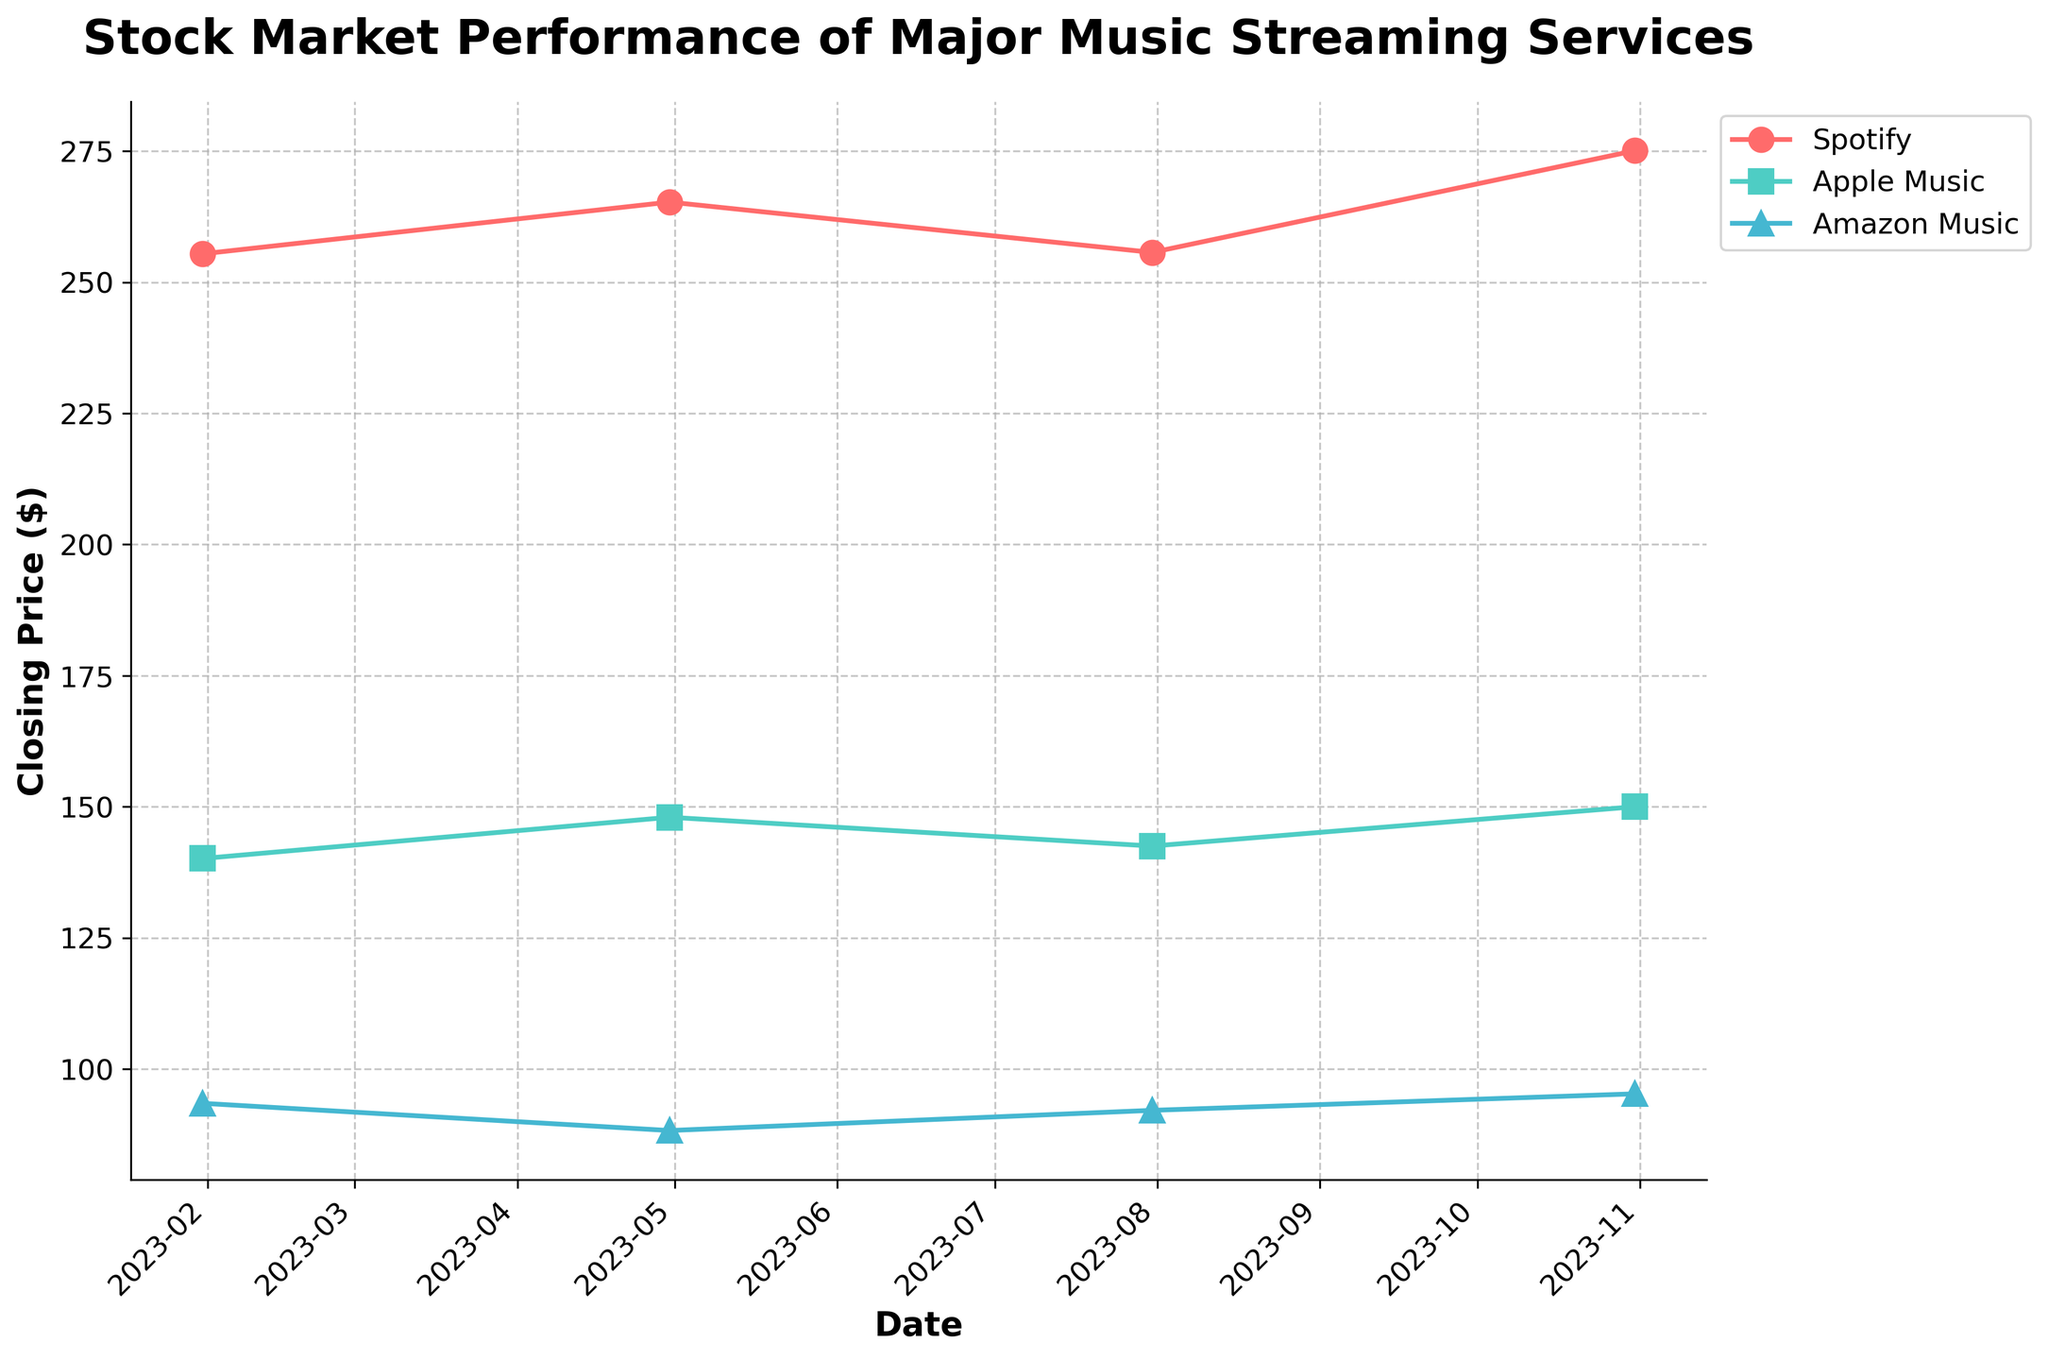What is the title of the figure? The title is located at the top of the figure, usually in a larger and bold font to indicate it's the main heading. The title summarizes the main topic or purpose of the figure.
Answer: Stock Market Performance of Major Music Streaming Services How many companies are represented in the figure? To find out how many companies are represented, look at the legends or lines on the plot. Each color and marker type represents a different company.
Answer: Three Which company has the highest closing price on January 31, 2023? Located the data points for January 31, 2023, and compare the closing prices among the companies. The company with the highest data point on that date is the answer.
Answer: Spotify Did Apple Music's stock price increase or decrease from July 31 to October 31, 2023? Compare the closing prices of Apple Music on July 31 and October 31, 2023. A higher value on October 31 indicates an increase, while a lower value indicates a decrease.
Answer: Increase What is the closing price of Amazon Music on July 31, 2023? Find the date July 31, 2023, on the x-axis, then look at Amazon Music’s line to find the corresponding y-value.
Answer: 92.10 Which company had the lowest closing price on October 31, 2023? Compare the closing prices of all companies on October 31, 2023. The lowest value among them will give the answer.
Answer: Amazon Music Between January 31, 2023, and April 30, 2023, which company showed the greatest increase in closing price? Calculate the difference in closing prices for each company between January 31 and April 30, 2023. The greatest positive difference indicates the company with the greatest increase.
Answer: Spotify What is the average closing price of Spotify across all the dates shown? To find the average, sum up the closing prices of Spotify on all the given dates and divide by the number of dates. Steps: (255.43 + 265.30 + 255.70 + 275.10) / 4 = 1051.53 / 4.
Answer: 262.88 Which quarter did Amazon Music have the lowest closing price? Compare the closing prices for Amazon Music in each quarter. The quarter with the lowest closing price will be the answer.
Answer: April 30, 2023 How does the closing price trend of Apple Music look from January to October 2023? Observe the line representing Apple Music from January to October 2023. Look for any upward, downward, or stable trends over the period.
Answer: Slightly increasing 